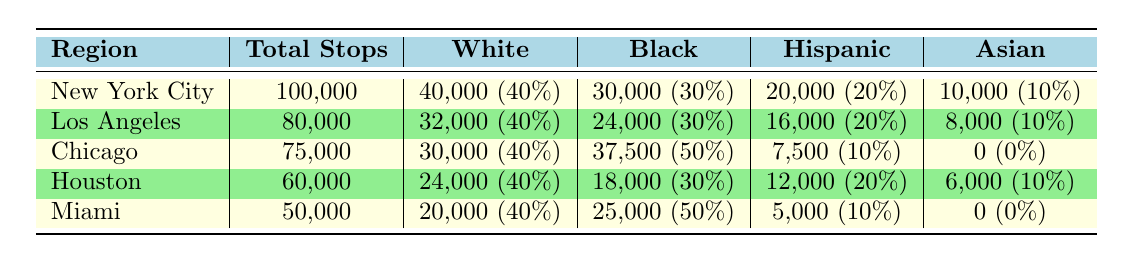What region had the highest number of total police stops? By evaluating the "Total Stops" column in the table, New York City has the highest total at 100,000 stops.
Answer: New York City What percentage of police stops in Chicago were Black individuals? The table shows that Black individuals accounted for 37,500 out of 75,000 stops in Chicago, which is 50%.
Answer: 50% How many White individuals were stopped in Los Angeles? The table indicates that 32,000 White individuals were stopped in Los Angeles.
Answer: 32,000 In which regions did Asian individuals account for zero stops? The table indicates that both Chicago and Miami have 0 stops for Asian individuals, as shown in their respective rows.
Answer: Chicago and Miami What is the total number of police stops for Hispanic individuals across all regions listed? To find the total, sum the Hispanic stops from each region: 20,000 (NYC) + 16,000 (LA) + 7,500 (Chicago) + 12,000 (Houston) + 5,000 (Miami) = 60,500.
Answer: 60,500 Was the percentage of Black individuals stopped higher in Miami than in Houston? Miami had 50% Black stops (25,000 out of 50,000) while Houston had 30% (18,000 out of 60,000). Since 50% is greater than 30%, the answer is yes.
Answer: Yes Which region had the lowest total number of police stops? By reviewing the "Total Stops" column, Miami has the lowest total with 50,000 stops.
Answer: Miami What is the average number of stops for White individuals across the five regions? The total number of stops for White individuals is 40,000 (NYC) + 32,000 (LA) + 30,000 (Chicago) + 24,000 (Houston) + 20,000 (Miami) = 146,000. The average would be calculated by dividing 146,000 by 5, which equals 29,200.
Answer: 29,200 Is it true that Los Angeles had a higher number of stops for Hispanic individuals than New York City? Los Angeles had 16,000 Hispanic stops and New York City had 20,000. Since 16,000 is less than 20,000, the statement is false.
Answer: No 